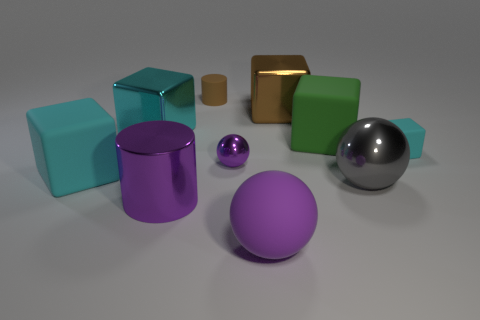Is the number of large cyan cubes that are to the right of the big gray thing less than the number of large cyan matte blocks?
Ensure brevity in your answer.  Yes. Are there any other small matte objects that have the same shape as the brown rubber object?
Your answer should be compact. No. The gray shiny thing that is the same size as the purple cylinder is what shape?
Your response must be concise. Sphere. What number of things are purple cylinders or large red metallic balls?
Your answer should be compact. 1. Are there any cyan rubber things?
Your response must be concise. Yes. Is the number of large gray spheres less than the number of large red matte balls?
Provide a succinct answer. No. Is there a purple matte object that has the same size as the brown matte cylinder?
Your answer should be very brief. No. There is a purple rubber object; is its shape the same as the big cyan thing behind the tiny purple ball?
Offer a terse response. No. What number of cylinders are tiny yellow objects or tiny purple things?
Offer a terse response. 0. What is the color of the small cube?
Make the answer very short. Cyan. 